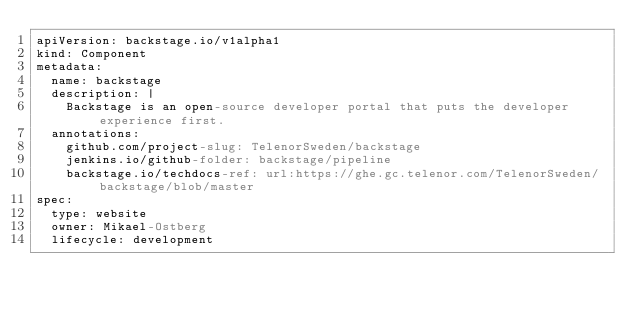Convert code to text. <code><loc_0><loc_0><loc_500><loc_500><_YAML_>apiVersion: backstage.io/v1alpha1
kind: Component
metadata:
  name: backstage
  description: |
    Backstage is an open-source developer portal that puts the developer experience first.
  annotations:
    github.com/project-slug: TelenorSweden/backstage
    jenkins.io/github-folder: backstage/pipeline
    backstage.io/techdocs-ref: url:https://ghe.gc.telenor.com/TelenorSweden/backstage/blob/master
spec:
  type: website
  owner: Mikael-Ostberg
  lifecycle: development
</code> 